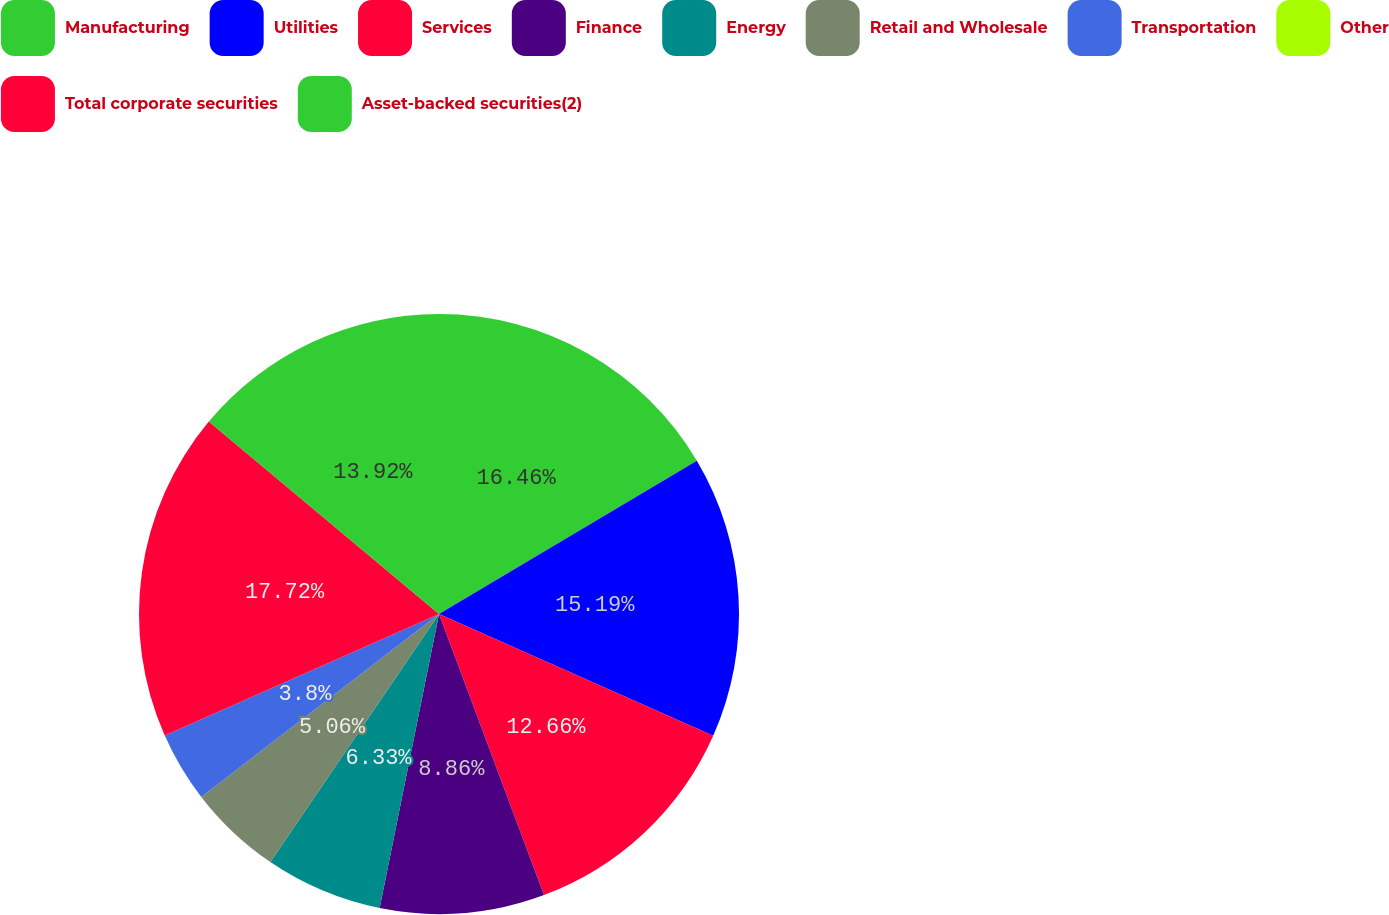Convert chart. <chart><loc_0><loc_0><loc_500><loc_500><pie_chart><fcel>Manufacturing<fcel>Utilities<fcel>Services<fcel>Finance<fcel>Energy<fcel>Retail and Wholesale<fcel>Transportation<fcel>Other<fcel>Total corporate securities<fcel>Asset-backed securities(2)<nl><fcel>16.46%<fcel>15.19%<fcel>12.66%<fcel>8.86%<fcel>6.33%<fcel>5.06%<fcel>3.8%<fcel>0.0%<fcel>17.72%<fcel>13.92%<nl></chart> 